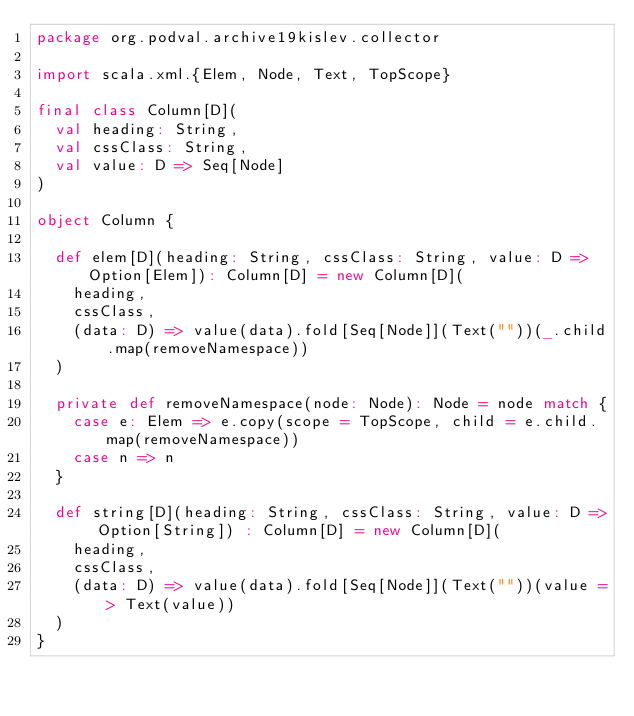Convert code to text. <code><loc_0><loc_0><loc_500><loc_500><_Scala_>package org.podval.archive19kislev.collector

import scala.xml.{Elem, Node, Text, TopScope}

final class Column[D](
  val heading: String,
  val cssClass: String,
  val value: D => Seq[Node]
)

object Column {

  def elem[D](heading: String, cssClass: String, value: D => Option[Elem]): Column[D] = new Column[D](
    heading,
    cssClass,
    (data: D) => value(data).fold[Seq[Node]](Text(""))(_.child.map(removeNamespace))
  )

  private def removeNamespace(node: Node): Node = node match {
    case e: Elem => e.copy(scope = TopScope, child = e.child.map(removeNamespace))
    case n => n
  }

  def string[D](heading: String, cssClass: String, value: D => Option[String]) : Column[D] = new Column[D](
    heading,
    cssClass,
    (data: D) => value(data).fold[Seq[Node]](Text(""))(value => Text(value))
  )
}
</code> 